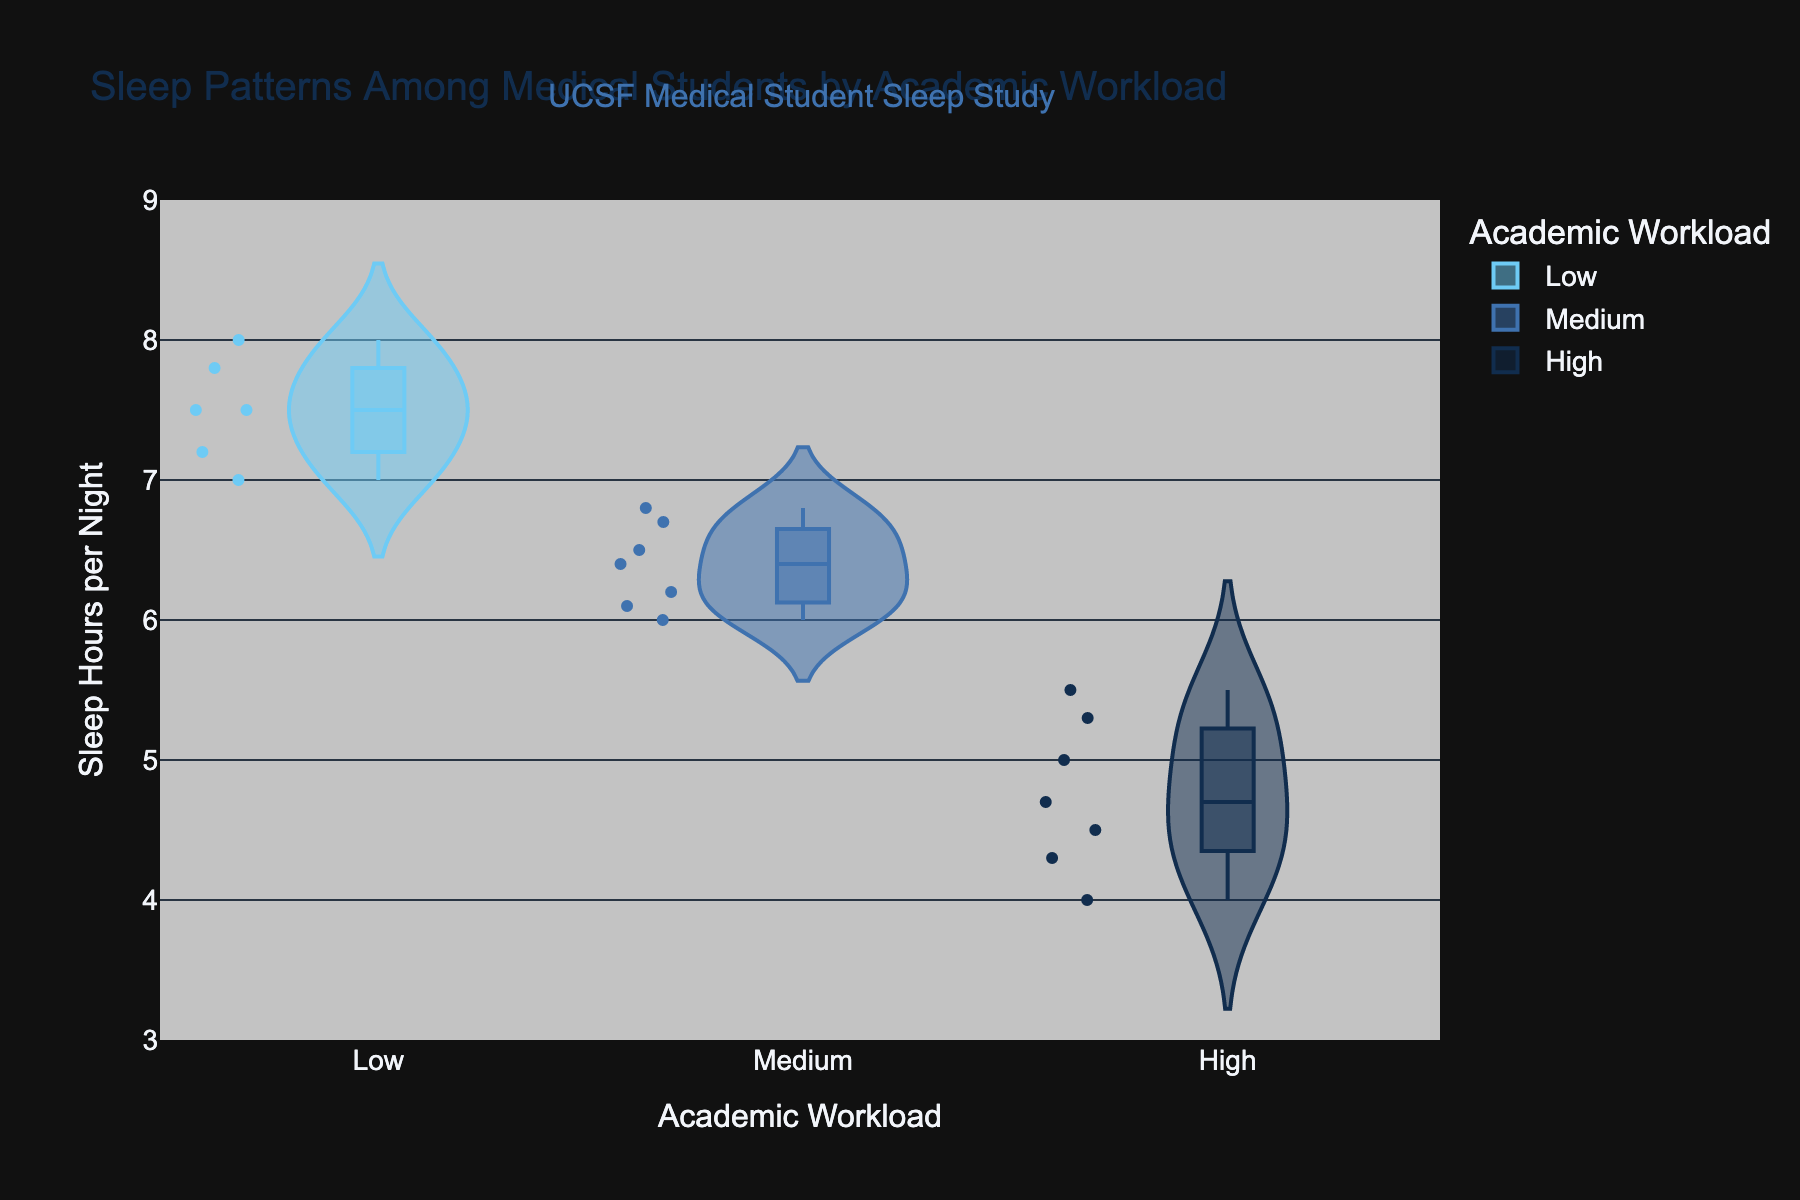What's the title of the figure? The title of a figure is typically displayed at the top and provides an overview of the data being presented.
Answer: Sleep Patterns Among Medical Students by Academic Workload What is the range of sleep hours per night displayed on the y-axis? The y-axis depicts sleep hours per night, and the axis range helps to understand the span of data values being analyzed. By examining the y-axis, it is apparent that it ranges from 3 to 9 hours.
Answer: 3 to 9 What color represents the 'High' academic workload? In the violin plot, different colors are used to differentiate between levels of academic workload. The legend for the plot indicates that the color for 'High' academic workload is a specific shade of dark blue.
Answer: Dark blue How many data points are there in the 'Low' academic workload group? Each group in the violin plot consists of individual data points marked by dots. By counting these dots in the 'Low' academic workload group, we can determine the number of data points.
Answer: 5 Which academic workload group has the highest median sleep hours per night? The median is represented by a central line within each violin plot. By comparing the median lines in each group, we can identify which group has the highest median sleep hours per night. The 'Low' group has the highest median.
Answer: Low What is the median sleep hours per night for the 'High' academic workload group? The median sleep hours for each group are shown as a line within each violin plot. The line within the 'High' category's plot indicates that the median sleep hours per night is around 5 hours.
Answer: 5 hours Which group shows the widest range of sleep hours per night? The range is indicated by the spread of the violin plot. By comparing the width of the plots, it can be determined that the 'High' academic workload group has the widest range of sleep hours, spanning from around 4 to 7 hours.
Answer: High Compare the average sleep hours per night between the 'Medium' and 'High' academic workload groups. To find the average, sum the sleep hours of all data points in the 'Medium' and 'High' groups and divide by the number of points in each group. Medium: (6.5+6.0+6.8+6.2+6.7+6.4+6.1)/7 = 6.24; High: (5.5+5.0+4.5+4.0+5.3+4.7+4.3)/7 = 4.9. Medium has a higher average.
Answer: Medium: 6.24, High: 4.9 How does extracurricular hours correlate with sleep hours within the 'High' group? By analyzing the hover data for each point in the 'High' academic workload group, a pattern can be observed. Higher extracurricular hours seem to correspond with lower sleep hours per night, showing a negative correlation.
Answer: Negative correlation What is the range of sleep hours in the 'Medium' academic workload group? The range is the difference between the maximum and minimum values in the dataset. By inspecting the 'Medium' academic workload group's violin plot, the sleep hours range from roughly 6.0 to 6.8.
Answer: 6.0 to 6.8 